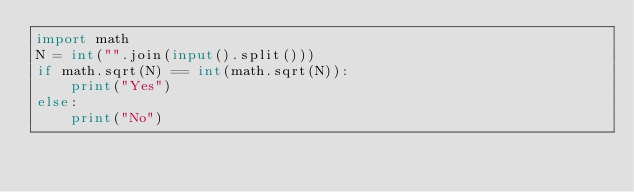Convert code to text. <code><loc_0><loc_0><loc_500><loc_500><_Python_>import math
N = int("".join(input().split()))
if math.sqrt(N) == int(math.sqrt(N)):
    print("Yes")
else:
    print("No")</code> 